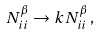<formula> <loc_0><loc_0><loc_500><loc_500>N ^ { \beta } _ { i i } \rightarrow k N ^ { \beta } _ { i i } \, ,</formula> 